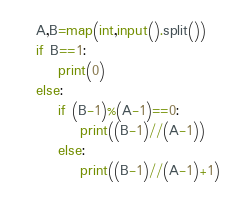<code> <loc_0><loc_0><loc_500><loc_500><_Python_>A,B=map(int,input().split())
if B==1:
    print(0)
else:
    if (B-1)%(A-1)==0:
        print((B-1)//(A-1))
    else:
        print((B-1)//(A-1)+1)</code> 